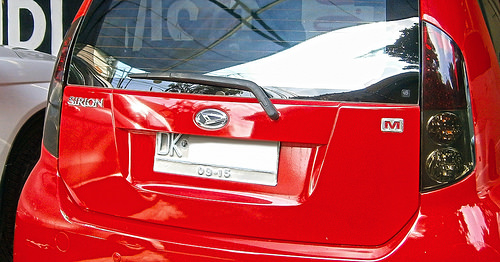<image>
Can you confirm if the wiper is next to the windshield? No. The wiper is not positioned next to the windshield. They are located in different areas of the scene. 